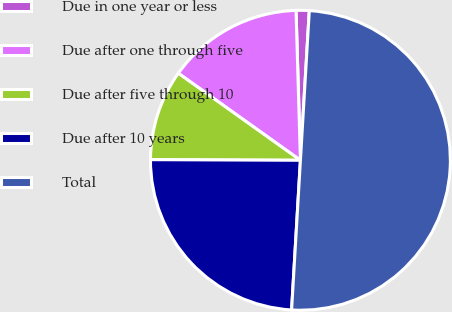<chart> <loc_0><loc_0><loc_500><loc_500><pie_chart><fcel>Due in one year or less<fcel>Due after one through five<fcel>Due after five through 10<fcel>Due after 10 years<fcel>Total<nl><fcel>1.41%<fcel>14.68%<fcel>9.79%<fcel>24.13%<fcel>50.0%<nl></chart> 